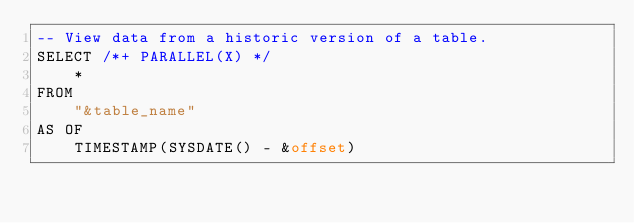Convert code to text. <code><loc_0><loc_0><loc_500><loc_500><_SQL_>-- View data from a historic version of a table.
SELECT /*+ PARALLEL(X) */
	*
FROM
	"&table_name"
AS OF
	TIMESTAMP(SYSDATE() - &offset)
</code> 